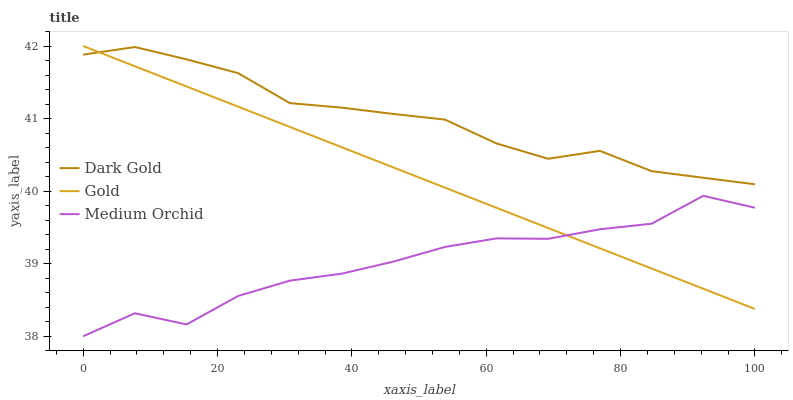Does Medium Orchid have the minimum area under the curve?
Answer yes or no. Yes. Does Dark Gold have the maximum area under the curve?
Answer yes or no. Yes. Does Gold have the minimum area under the curve?
Answer yes or no. No. Does Gold have the maximum area under the curve?
Answer yes or no. No. Is Gold the smoothest?
Answer yes or no. Yes. Is Medium Orchid the roughest?
Answer yes or no. Yes. Is Dark Gold the smoothest?
Answer yes or no. No. Is Dark Gold the roughest?
Answer yes or no. No. Does Medium Orchid have the lowest value?
Answer yes or no. Yes. Does Gold have the lowest value?
Answer yes or no. No. Does Gold have the highest value?
Answer yes or no. Yes. Does Dark Gold have the highest value?
Answer yes or no. No. Is Medium Orchid less than Dark Gold?
Answer yes or no. Yes. Is Dark Gold greater than Medium Orchid?
Answer yes or no. Yes. Does Gold intersect Dark Gold?
Answer yes or no. Yes. Is Gold less than Dark Gold?
Answer yes or no. No. Is Gold greater than Dark Gold?
Answer yes or no. No. Does Medium Orchid intersect Dark Gold?
Answer yes or no. No. 